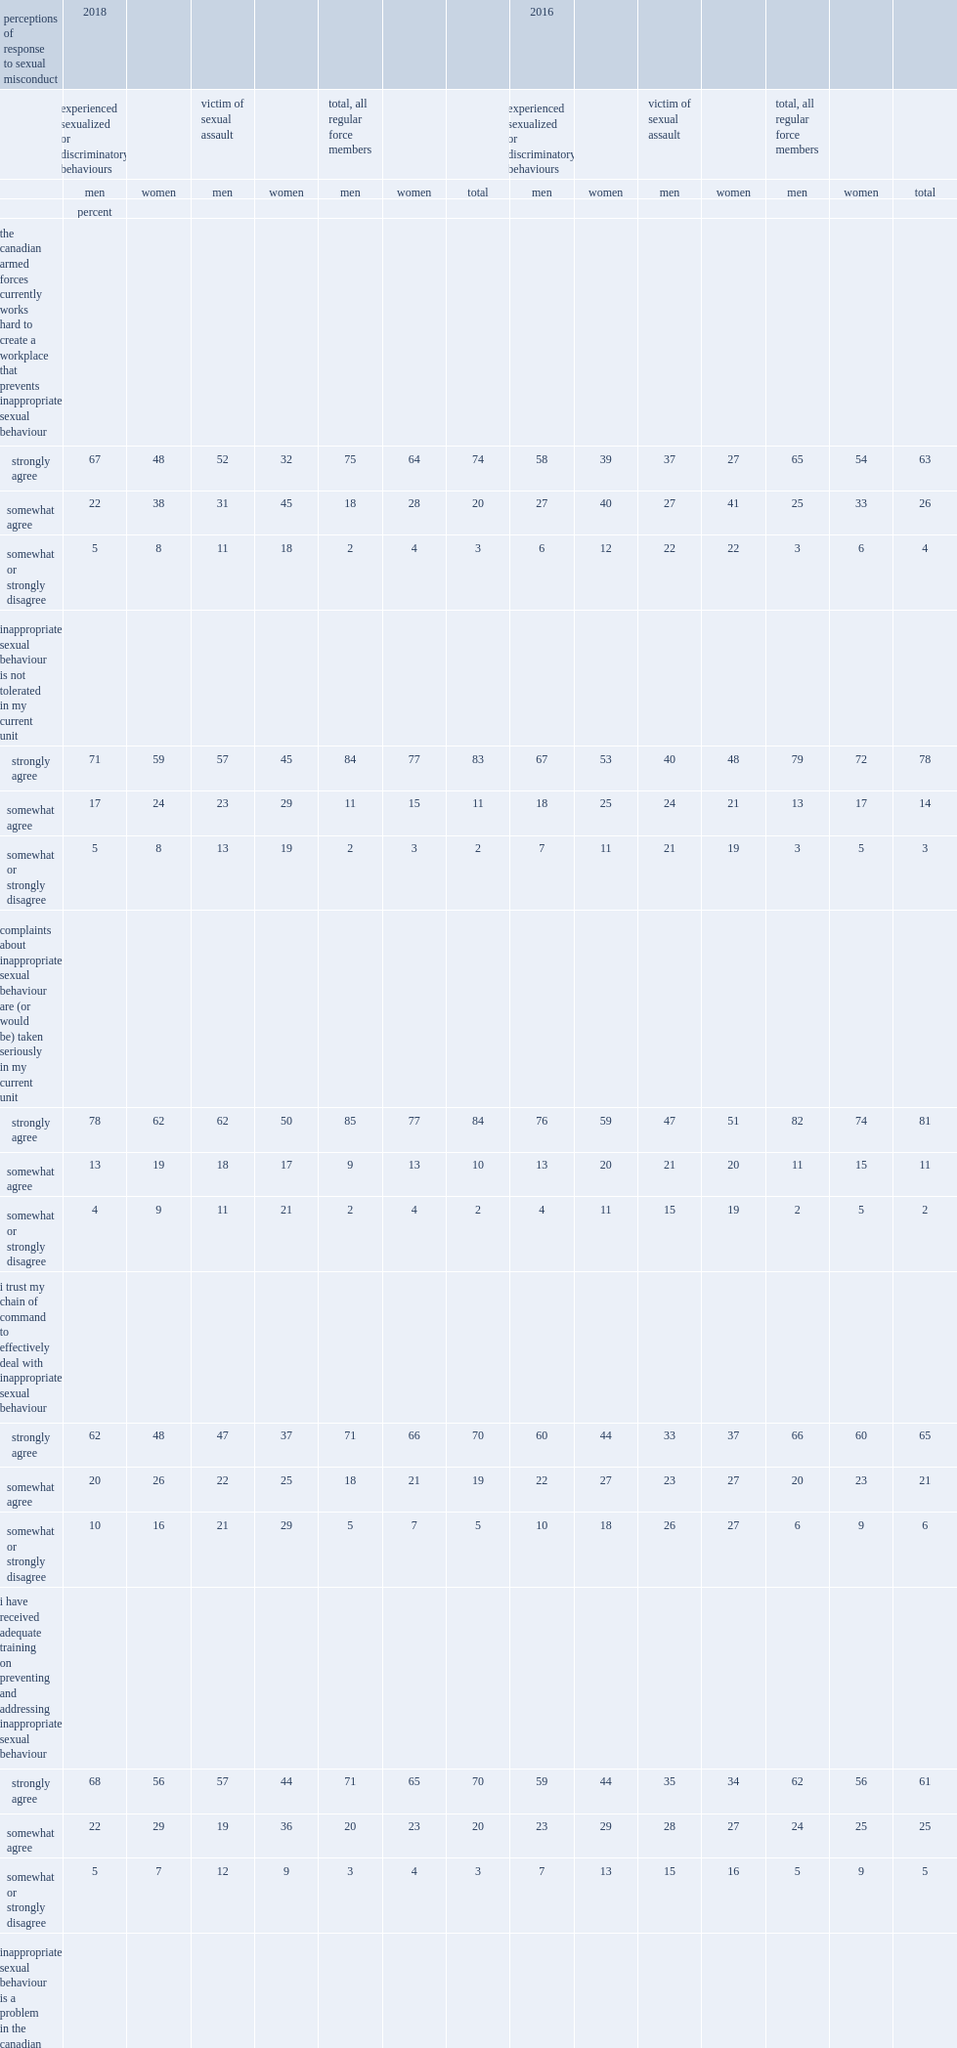In 2018, what is the proportion of regular force members who agreed that inappropriate sexual behaviour is not tolerated in their current unit? 94. In 2018, what is the proportion of regular force members who strongly agreed that inappropriate sexual behaviour is not tolerated in their current unit? 83.0. In 2018, what is the proportion of regular force members who agreed that complaints are or would be taken seriously in their current unit? 94. In 2018, what is the proportion of regular force members who strongly agreed that complaints are or would be taken seriously in their current unit? 84.0. Which years's proportion of regular force members who strongly agreed that inappropriate sexual behaviour is not tolerated in their current unit was higher, 2018 or 2016? 2018.0. Which years's proportion of regular force members who strongly agreed that complaints about inappropriate sexual behaviour are or would be taken seriously in my current unit was higher, 2018 or 2016? 2018.0. In 2018, what is the proportion of regular force members who strongly agreed that caf is working hard to create a workplace that prevents inappropriate sexual behaviour? 74.0. How many percentage points was the percentage of regular force members who strongly agreed that caf is working hard to create a workplace that prevents inappropriate sexual behaviour in 2018 higher than that in 2016? 11. In 2018, what is the percentage of regular force members who trusted their chain of command to effectively deal with inappropriate sexual behaviour? 89. In 2018, among which gender was the percentage of regular force members who trusted their chain of command to effectively deal with inappropriate sexual behaviour slightly higher? Men. In 2018, what was the proportion of men who did not trust their chain of command after experiencing sexual or discriminatory behaviour? 10.0. In 2018, what was the proportion of women who did not trust their chain of command after experiencing sexual or discriminatory behaviour? 16.0. In 2018, what was the proportion of men who did not trust their chain of command after being sexually assaulted? 21.0. In 2018, what was the proportion of women who did not trust their chain of command after being sexually assaulted? 29.0. 